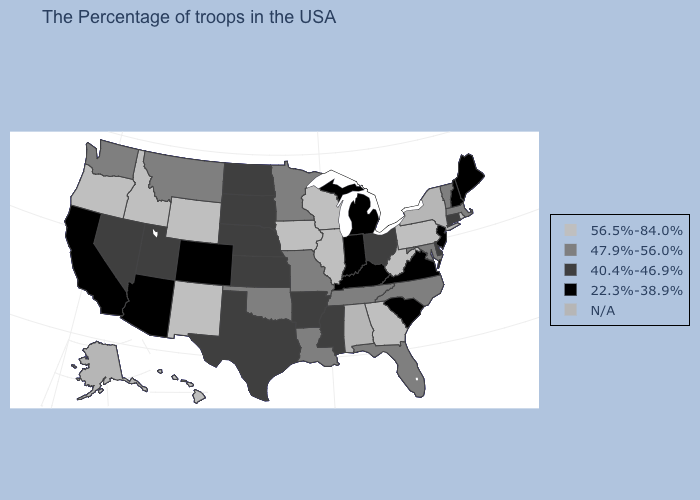What is the value of Connecticut?
Keep it brief. 40.4%-46.9%. What is the lowest value in the USA?
Answer briefly. 22.3%-38.9%. Which states have the highest value in the USA?
Write a very short answer. Rhode Island, Pennsylvania, West Virginia, Georgia, Wisconsin, Illinois, Iowa, Wyoming, New Mexico, Idaho, Oregon, Hawaii. Name the states that have a value in the range 22.3%-38.9%?
Quick response, please. Maine, New Hampshire, New Jersey, Virginia, South Carolina, Michigan, Kentucky, Indiana, Colorado, Arizona, California. Name the states that have a value in the range 56.5%-84.0%?
Give a very brief answer. Rhode Island, Pennsylvania, West Virginia, Georgia, Wisconsin, Illinois, Iowa, Wyoming, New Mexico, Idaho, Oregon, Hawaii. Which states hav the highest value in the Northeast?
Be succinct. Rhode Island, Pennsylvania. What is the lowest value in states that border Rhode Island?
Concise answer only. 40.4%-46.9%. Name the states that have a value in the range 40.4%-46.9%?
Keep it brief. Connecticut, Delaware, Ohio, Mississippi, Arkansas, Kansas, Nebraska, Texas, South Dakota, North Dakota, Utah, Nevada. Name the states that have a value in the range 56.5%-84.0%?
Write a very short answer. Rhode Island, Pennsylvania, West Virginia, Georgia, Wisconsin, Illinois, Iowa, Wyoming, New Mexico, Idaho, Oregon, Hawaii. Name the states that have a value in the range 56.5%-84.0%?
Short answer required. Rhode Island, Pennsylvania, West Virginia, Georgia, Wisconsin, Illinois, Iowa, Wyoming, New Mexico, Idaho, Oregon, Hawaii. Does Illinois have the lowest value in the MidWest?
Write a very short answer. No. Name the states that have a value in the range 56.5%-84.0%?
Write a very short answer. Rhode Island, Pennsylvania, West Virginia, Georgia, Wisconsin, Illinois, Iowa, Wyoming, New Mexico, Idaho, Oregon, Hawaii. Which states have the highest value in the USA?
Write a very short answer. Rhode Island, Pennsylvania, West Virginia, Georgia, Wisconsin, Illinois, Iowa, Wyoming, New Mexico, Idaho, Oregon, Hawaii. Name the states that have a value in the range 56.5%-84.0%?
Keep it brief. Rhode Island, Pennsylvania, West Virginia, Georgia, Wisconsin, Illinois, Iowa, Wyoming, New Mexico, Idaho, Oregon, Hawaii. Name the states that have a value in the range 56.5%-84.0%?
Answer briefly. Rhode Island, Pennsylvania, West Virginia, Georgia, Wisconsin, Illinois, Iowa, Wyoming, New Mexico, Idaho, Oregon, Hawaii. 